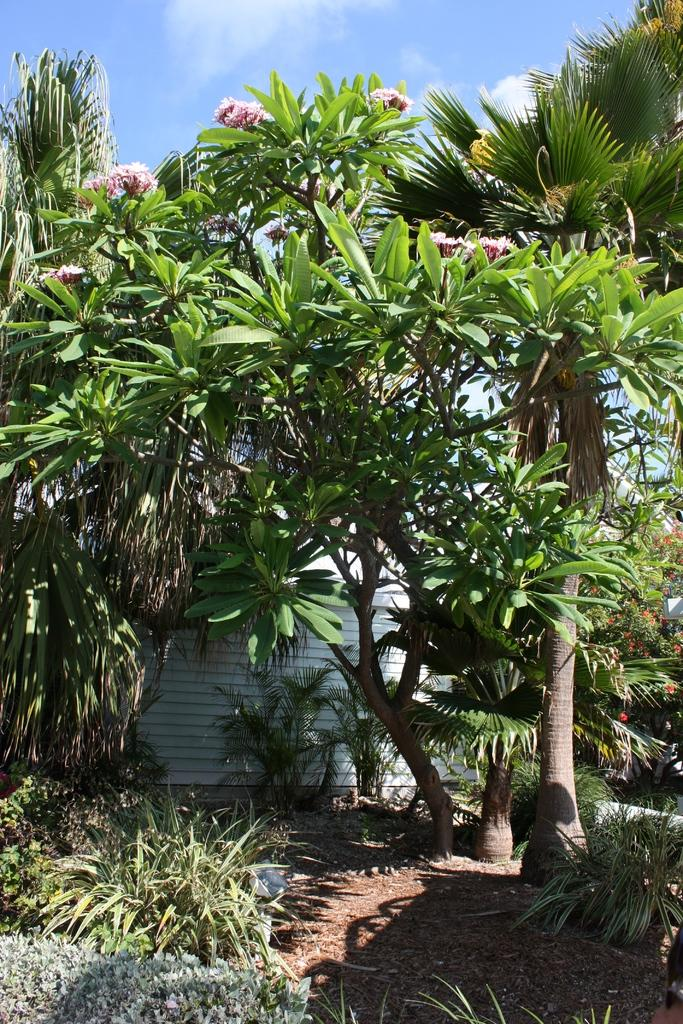What type of structure is present in the image? There is a wall in the image. What type of natural elements can be seen in the image? There are trees, plants, and bushes in the image. Are there any specific features on one of the plants in the image? Yes, there are flowers on one plant in the image. What is visible at the top of the image? The sky is visible at the top of the image. What type of soda is being poured into the cup in the image? There is no soda or cup present in the image. What type of animal can be seen interacting with the plants in the image? There are no animals present in the image; it only features plants, trees, bushes, and a wall. 